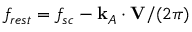Convert formula to latex. <formula><loc_0><loc_0><loc_500><loc_500>f _ { r e s t } = f _ { s c } - k _ { A } \cdot V / ( 2 \pi )</formula> 